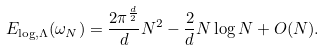<formula> <loc_0><loc_0><loc_500><loc_500>E _ { \log , \Lambda } ( \omega _ { N } ) = \frac { 2 \pi ^ { \frac { d } { 2 } } } { d } N ^ { 2 } - \frac { 2 } { d } N \log N + O ( N ) .</formula> 